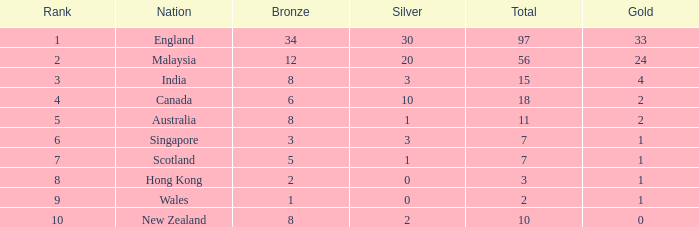What is the most gold medals a team with less than 2 silvers, more than 7 total medals, and less than 8 bronze medals has? None. 